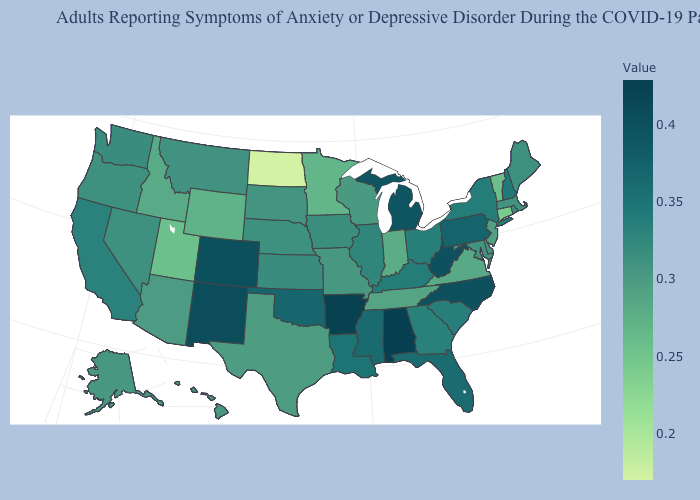Does Utah have the lowest value in the West?
Keep it brief. Yes. Does Texas have the highest value in the USA?
Keep it brief. No. Which states have the lowest value in the MidWest?
Answer briefly. North Dakota. Which states have the lowest value in the USA?
Concise answer only. North Dakota. Which states have the highest value in the USA?
Keep it brief. Alabama. Does West Virginia have a lower value than Nebraska?
Write a very short answer. No. 